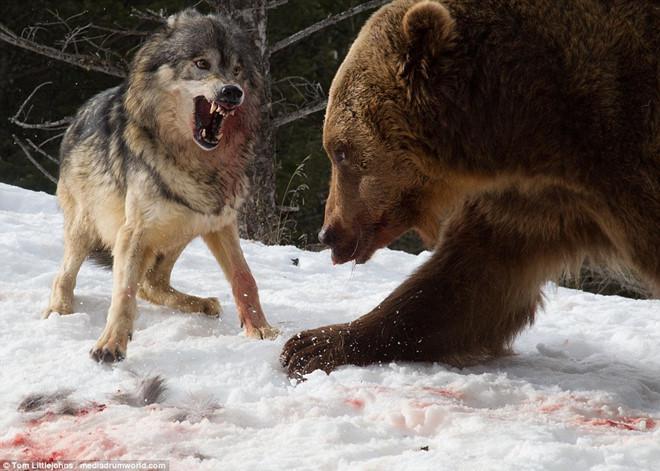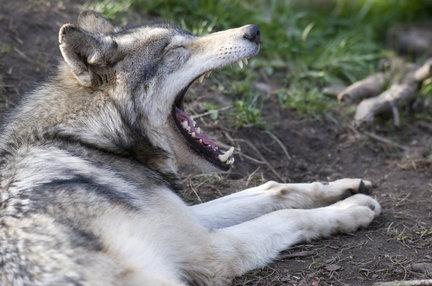The first image is the image on the left, the second image is the image on the right. Analyze the images presented: Is the assertion "The combined images contain three live animals, two animals have wide-open mouths, and at least two of the animals are wolves." valid? Answer yes or no. Yes. The first image is the image on the left, the second image is the image on the right. For the images shown, is this caption "There are three wolves." true? Answer yes or no. No. 